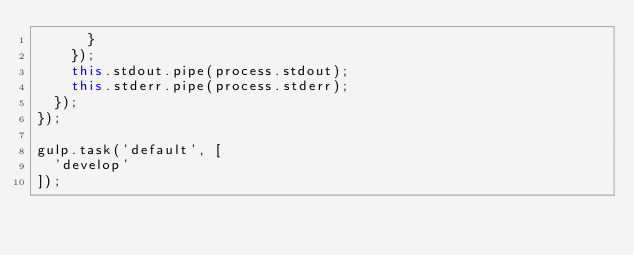Convert code to text. <code><loc_0><loc_0><loc_500><loc_500><_JavaScript_>      }
    });
    this.stdout.pipe(process.stdout);
    this.stderr.pipe(process.stderr);
  });
});

gulp.task('default', [
  'develop'
]);
</code> 